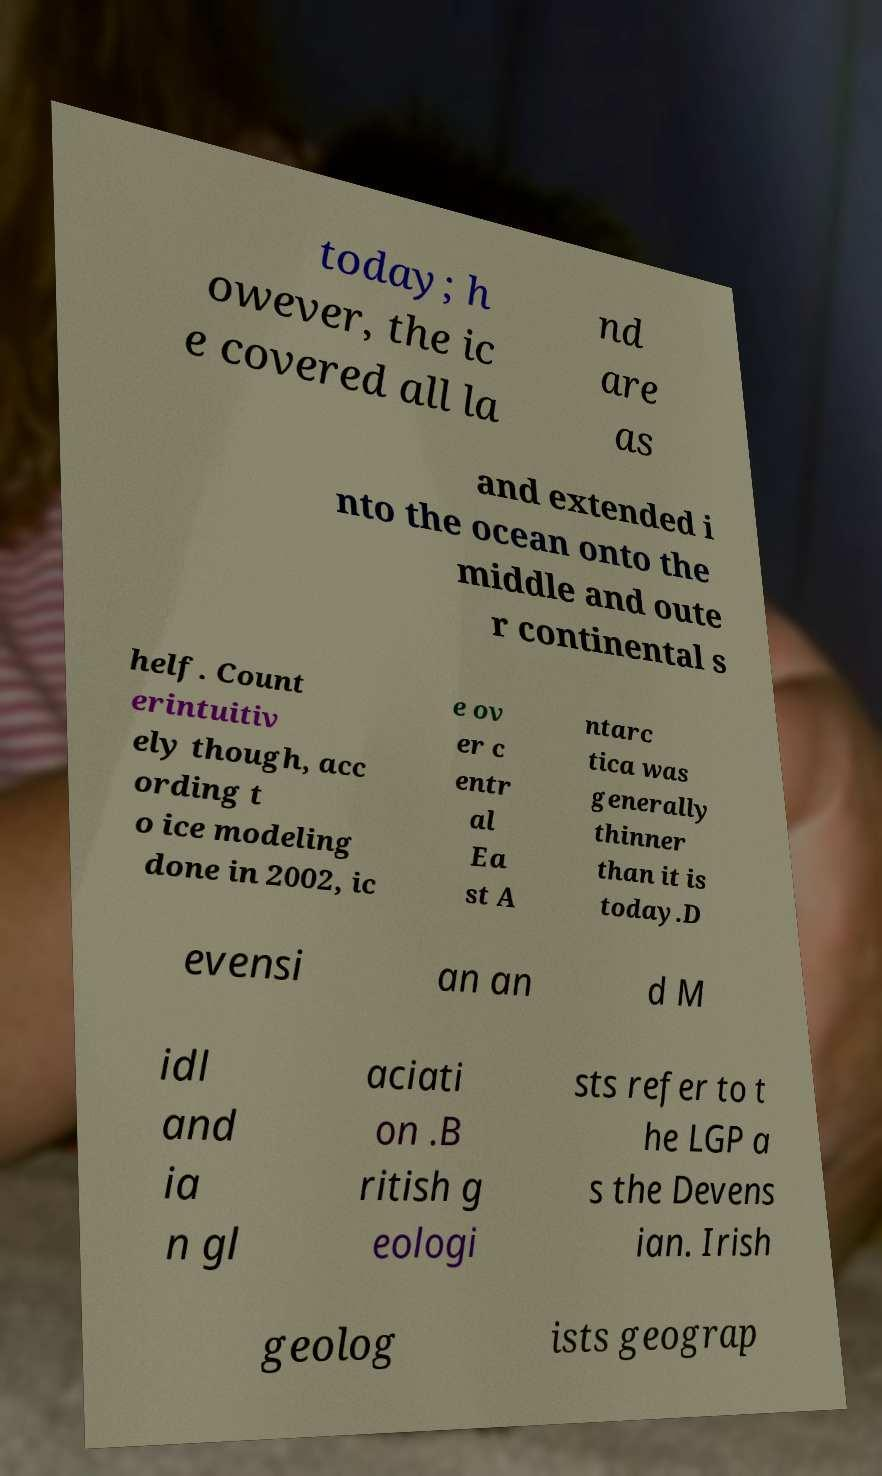Could you assist in decoding the text presented in this image and type it out clearly? today; h owever, the ic e covered all la nd are as and extended i nto the ocean onto the middle and oute r continental s helf. Count erintuitiv ely though, acc ording t o ice modeling done in 2002, ic e ov er c entr al Ea st A ntarc tica was generally thinner than it is today.D evensi an an d M idl and ia n gl aciati on .B ritish g eologi sts refer to t he LGP a s the Devens ian. Irish geolog ists geograp 